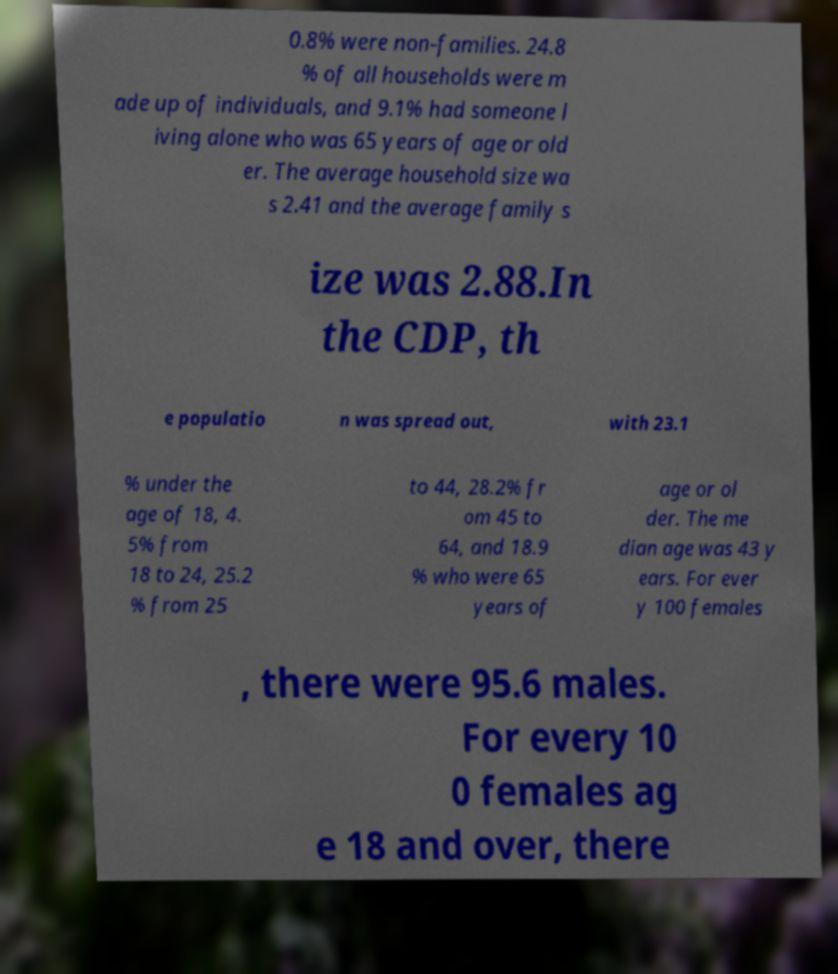Could you extract and type out the text from this image? 0.8% were non-families. 24.8 % of all households were m ade up of individuals, and 9.1% had someone l iving alone who was 65 years of age or old er. The average household size wa s 2.41 and the average family s ize was 2.88.In the CDP, th e populatio n was spread out, with 23.1 % under the age of 18, 4. 5% from 18 to 24, 25.2 % from 25 to 44, 28.2% fr om 45 to 64, and 18.9 % who were 65 years of age or ol der. The me dian age was 43 y ears. For ever y 100 females , there were 95.6 males. For every 10 0 females ag e 18 and over, there 